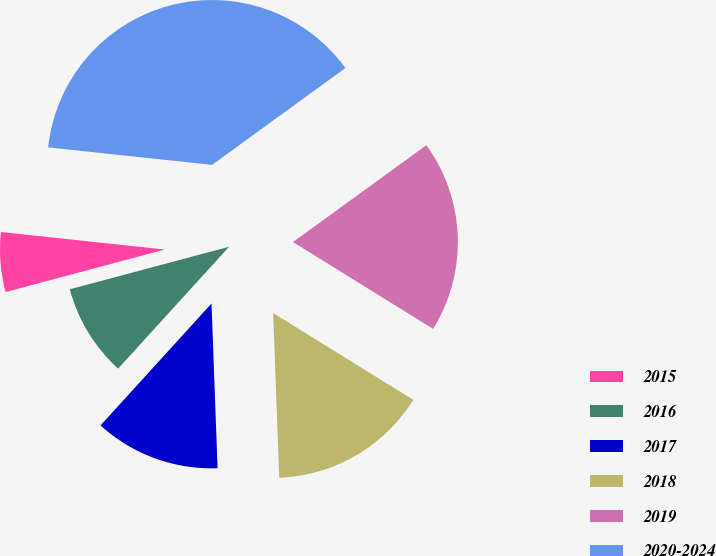Convert chart to OTSL. <chart><loc_0><loc_0><loc_500><loc_500><pie_chart><fcel>2015<fcel>2016<fcel>2017<fcel>2018<fcel>2019<fcel>2020-2024<nl><fcel>5.85%<fcel>9.09%<fcel>12.34%<fcel>15.58%<fcel>18.83%<fcel>38.31%<nl></chart> 